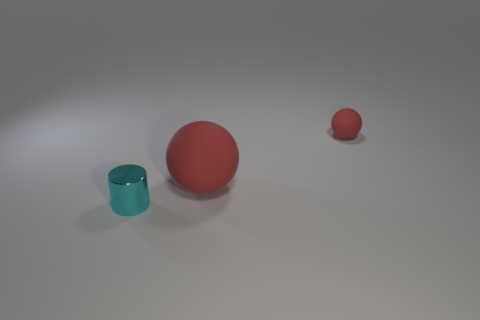Subtract 1 spheres. How many spheres are left? 1 Add 1 big red rubber things. How many objects exist? 4 Subtract all cylinders. How many objects are left? 2 Subtract 1 cyan cylinders. How many objects are left? 2 Subtract all yellow balls. Subtract all cyan cubes. How many balls are left? 2 Subtract all tiny red matte spheres. Subtract all cylinders. How many objects are left? 1 Add 2 shiny cylinders. How many shiny cylinders are left? 3 Add 2 large balls. How many large balls exist? 3 